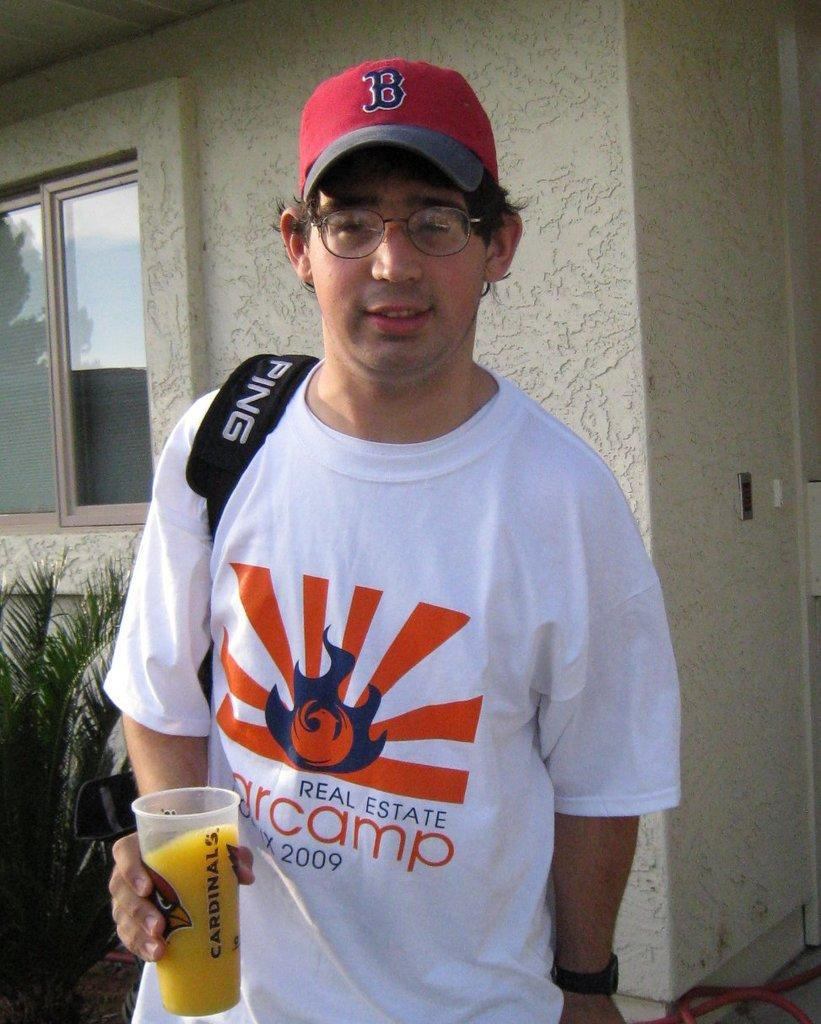<image>
Present a compact description of the photo's key features. A man in a white shirt holding a glass of juice with Cardinals written on it. 